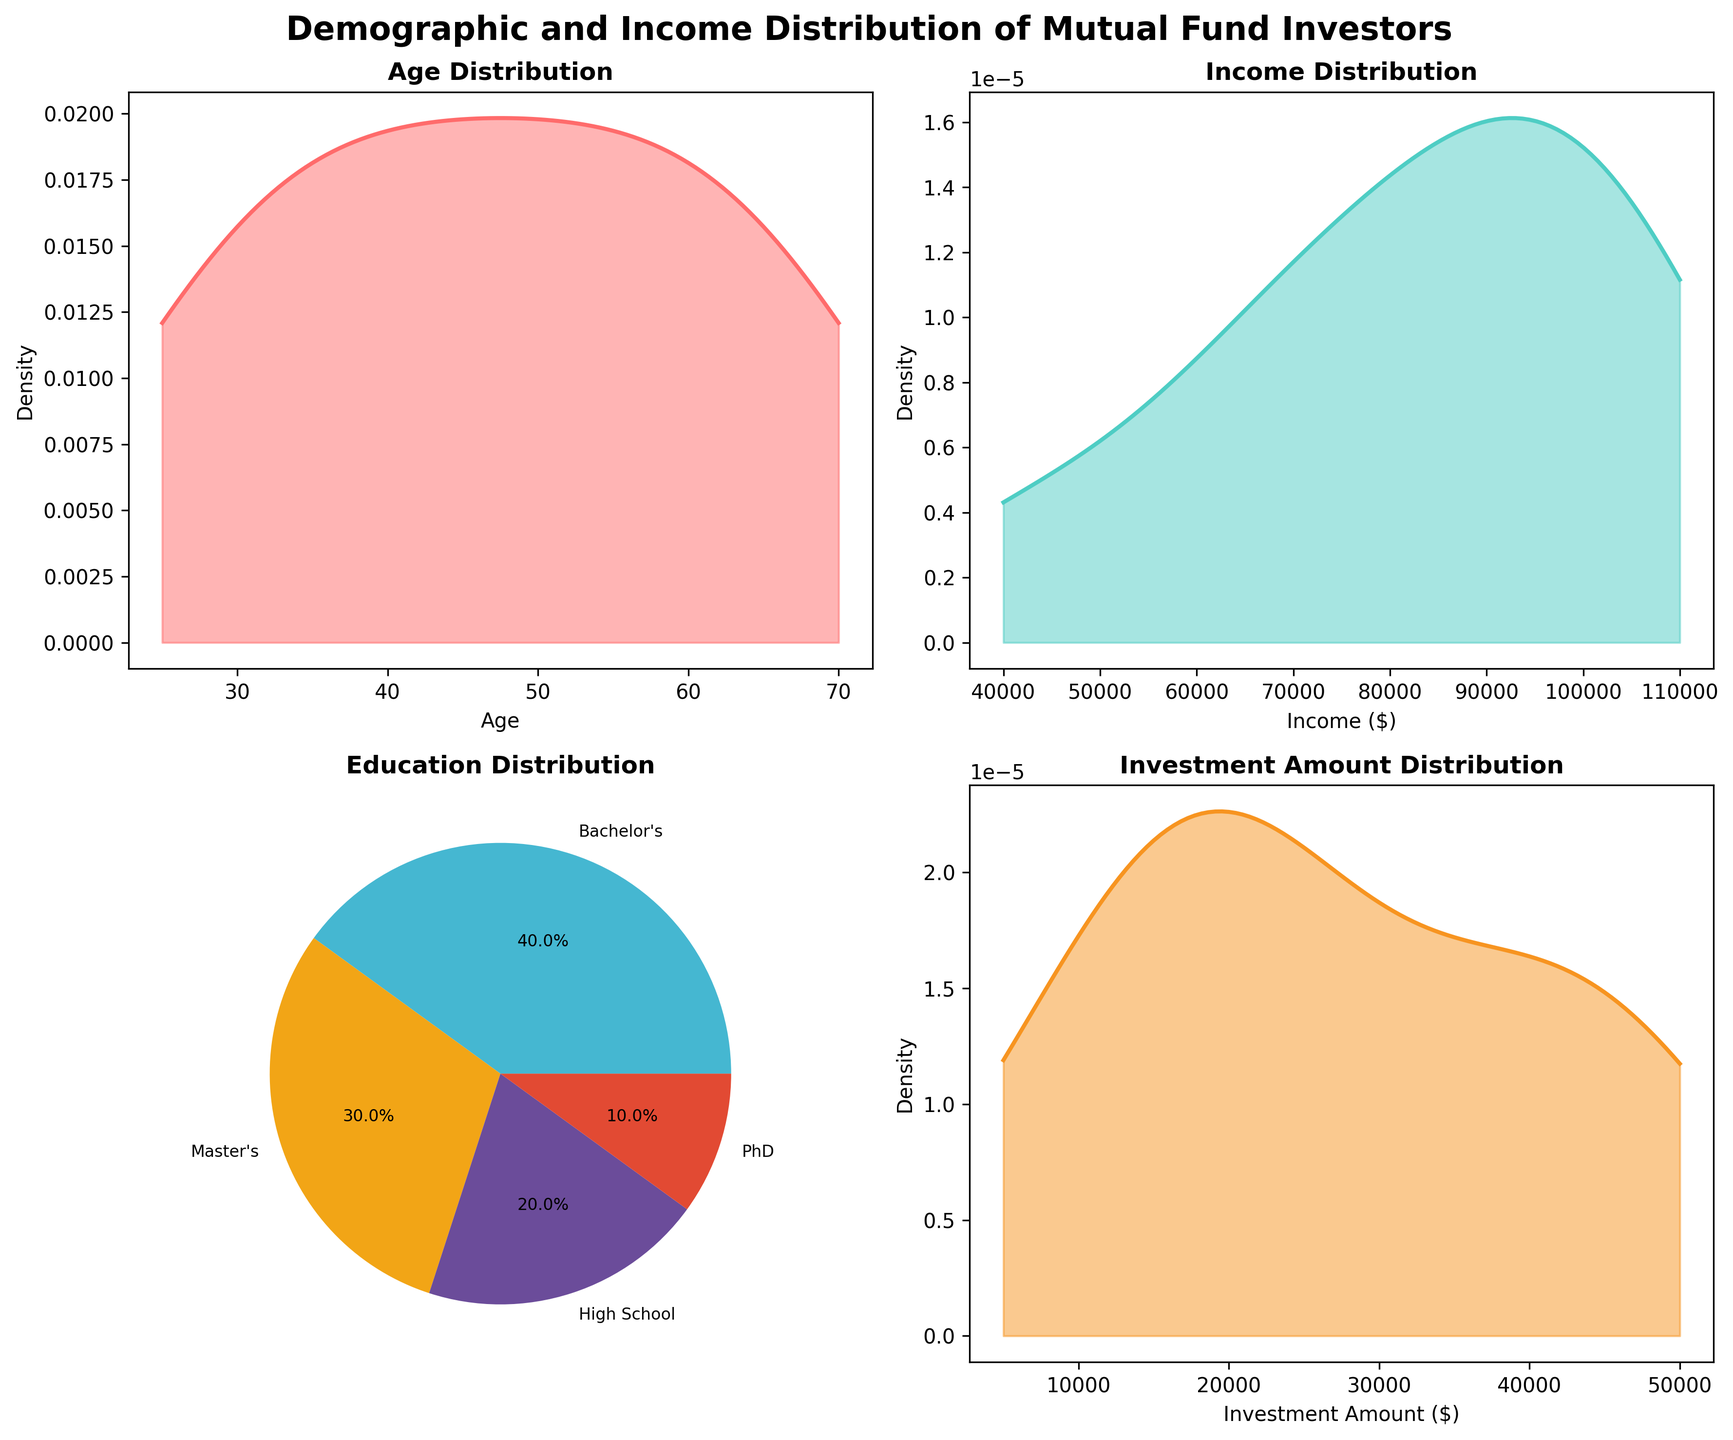What's the title of the figure? The title is located at the top of the figure and is written in a large, bold font. It reads "Demographic and Income Distribution of Mutual Fund Investors."
Answer: Demographic and Income Distribution of Mutual Fund Investors What kind of plot shows the age distribution? The subplot in the top-left corner displays the age distribution using a density plot, which is identified by a smooth line and shaded area.
Answer: Density plot How many categories of education are represented in the pie chart? The pie chart in the bottom-left corner of the figure shows the education distribution. There are four distinct segments with labels indicating the categories.
Answer: Four Between what age ranges does the age density plot cover? Looking at the x-axis of the age density plot in the top-left corner, it starts at 25 and ends at 70, covering this entire range.
Answer: 25 to 70 Which data point has the highest peak in the income distribution? The income density plot in the top-right corner shows the peak at a specific income value. Observing the tallest point of the curve indicates an income around 100,000 dollars.
Answer: Around $100,000 Which education level has the highest representation in the pie chart? The largest segment of the pie chart in the bottom-left corner, representing education, is labeled with a percentage and category name. This is the "Bachelor's" segment.
Answer: Bachelor's Describe the shape of the investment amount distribution plot. Examining the density plot in the bottom-right corner for investment amount, it shows a smooth curve with a distinct peak, indicating the distribution's general tendency.
Answer: Smooth curve with a peak How does the range of values compare between the income and investment amount plots? The x-axis ranges of the different plots show that the income distribution ranges from $40,000 to $110,000 while the investment amount distribution ranges roughly from $5,000 to $50,000. This indicates that incomes tend to be higher compared to the investment amounts.
Answer: Income: $40,000 to $110,000; Investment Amount: $5,000 to $50,000 What percentage of investors have a Master’s degree? The pie chart representing education levels includes segments that provide the percentages. The segment labeled "Master's" reveals the exact percentage.
Answer: 30% Compare the density peaks of age and income distributions. Which one is higher? By comparing the heights of the peaks in the top-left (age) and top-right (income) density plots, the income distribution's peak is higher, indicating a more concentrated distribution around that peak value.
Answer: Income distribution peak is higher 